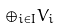<formula> <loc_0><loc_0><loc_500><loc_500>\oplus _ { i \in I } V _ { i }</formula> 